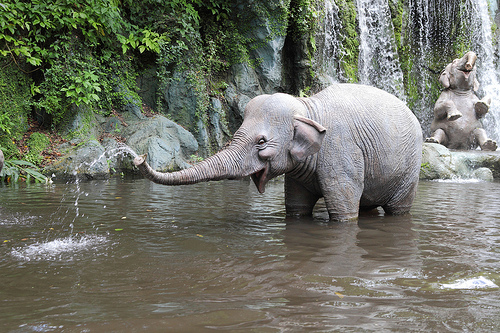Can you describe the setting in which the elephant is found? The elephant is in a natural setting with what appears to be a jungle environment. It's standing in a body of water with a waterfall in the backdrop, suggestive of a river or pond within a forested area. 